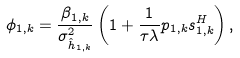Convert formula to latex. <formula><loc_0><loc_0><loc_500><loc_500>\phi _ { 1 , k } = \frac { \beta _ { 1 , k } } { \sigma _ { \hat { h } _ { 1 , k } } ^ { 2 } } \left ( 1 + \frac { 1 } { \tau \lambda } p _ { 1 , k } s _ { 1 , k } ^ { H } \right ) ,</formula> 